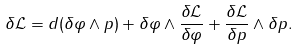Convert formula to latex. <formula><loc_0><loc_0><loc_500><loc_500>\delta { \mathcal { L } } = d ( \delta \varphi \wedge p ) + \delta \varphi \wedge \frac { \delta { \mathcal { L } } } { \delta \varphi } + \frac { \delta { \mathcal { L } } } { \delta p } \wedge \delta p .</formula> 